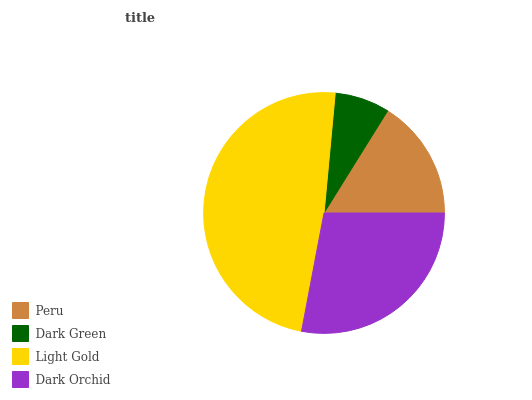Is Dark Green the minimum?
Answer yes or no. Yes. Is Light Gold the maximum?
Answer yes or no. Yes. Is Light Gold the minimum?
Answer yes or no. No. Is Dark Green the maximum?
Answer yes or no. No. Is Light Gold greater than Dark Green?
Answer yes or no. Yes. Is Dark Green less than Light Gold?
Answer yes or no. Yes. Is Dark Green greater than Light Gold?
Answer yes or no. No. Is Light Gold less than Dark Green?
Answer yes or no. No. Is Dark Orchid the high median?
Answer yes or no. Yes. Is Peru the low median?
Answer yes or no. Yes. Is Dark Green the high median?
Answer yes or no. No. Is Dark Orchid the low median?
Answer yes or no. No. 